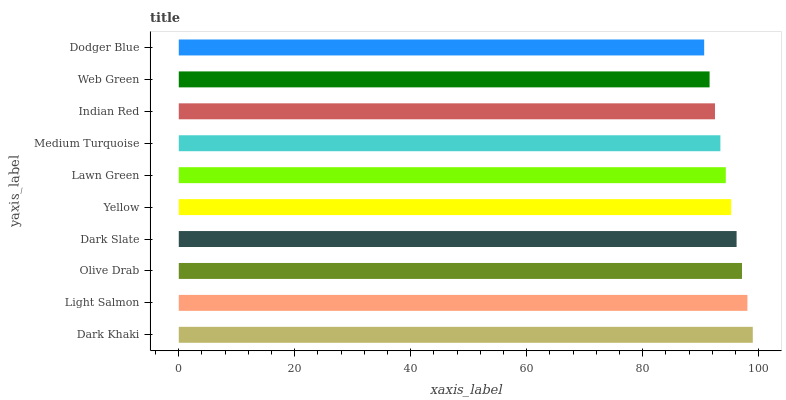Is Dodger Blue the minimum?
Answer yes or no. Yes. Is Dark Khaki the maximum?
Answer yes or no. Yes. Is Light Salmon the minimum?
Answer yes or no. No. Is Light Salmon the maximum?
Answer yes or no. No. Is Dark Khaki greater than Light Salmon?
Answer yes or no. Yes. Is Light Salmon less than Dark Khaki?
Answer yes or no. Yes. Is Light Salmon greater than Dark Khaki?
Answer yes or no. No. Is Dark Khaki less than Light Salmon?
Answer yes or no. No. Is Yellow the high median?
Answer yes or no. Yes. Is Lawn Green the low median?
Answer yes or no. Yes. Is Dark Khaki the high median?
Answer yes or no. No. Is Dodger Blue the low median?
Answer yes or no. No. 